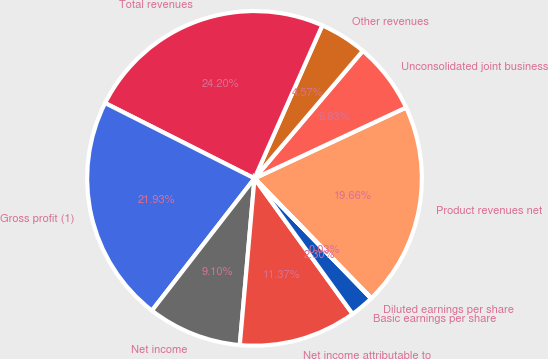Convert chart to OTSL. <chart><loc_0><loc_0><loc_500><loc_500><pie_chart><fcel>Product revenues net<fcel>Unconsolidated joint business<fcel>Other revenues<fcel>Total revenues<fcel>Gross profit (1)<fcel>Net income<fcel>Net income attributable to<fcel>Basic earnings per share<fcel>Diluted earnings per share<nl><fcel>19.66%<fcel>6.83%<fcel>4.57%<fcel>24.2%<fcel>21.93%<fcel>9.1%<fcel>11.37%<fcel>2.3%<fcel>0.03%<nl></chart> 